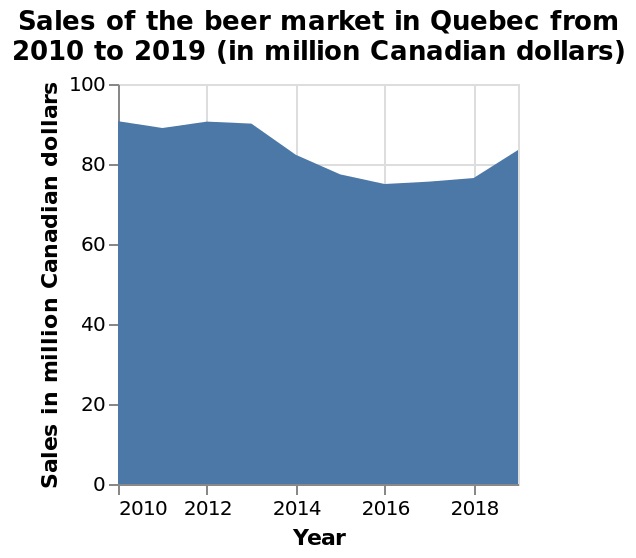<image>
What is the range of values represented on the y-axis in the beer market sales graph in Quebec? The range of values represented on the y-axis is in million Canadian dollars. Did sales increase or decrease from 2014-2017 according to the chart?  According to the chart, there was a decrease in sales from 2014-2017. What is the unit of measurement for the y-axis in the beer market sales graph in Quebec?  The unit of measurement for the y-axis in the graph is million Canadian dollars. Is the unit of measurement for the y-axis in the graph billion Canadian dollars? No. The unit of measurement for the y-axis in the graph is million Canadian dollars. 